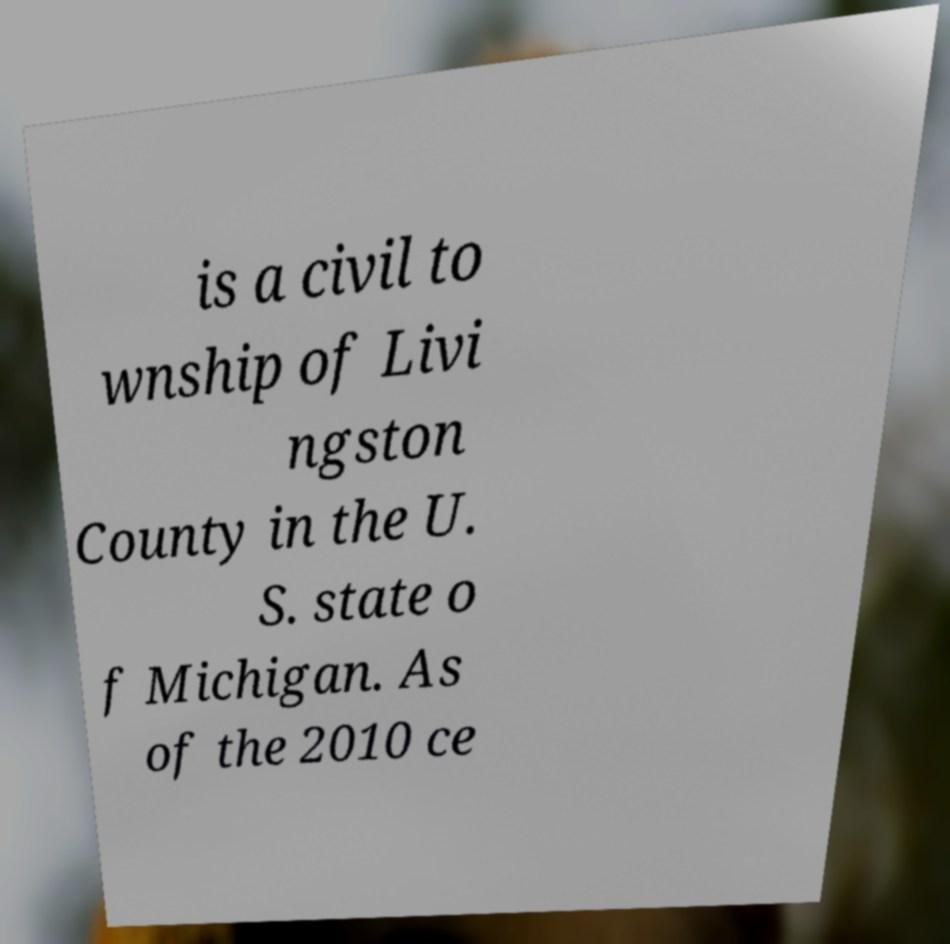Can you read and provide the text displayed in the image?This photo seems to have some interesting text. Can you extract and type it out for me? is a civil to wnship of Livi ngston County in the U. S. state o f Michigan. As of the 2010 ce 